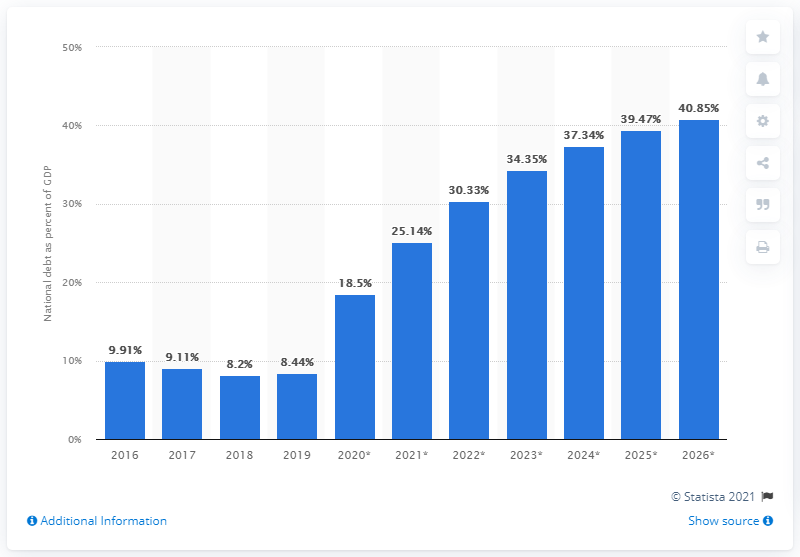What information does the chart provide about Estonia's national debt? The chart displays Estonia's national debt as a percentage of GDP from 2016 to 2026. The figures for 2021 to 2026 are projections. The trend indicates an increase in the national debt relative to GDP over the years, with a marked uptick in the projected values from 2021 onwards. What could be the reason for the projected increase in national debt? The projected increase in national debt could be attributed to various factors, such as government investment in public services or infrastructure, economic stimulus measures, or the impacts of global economic challenges such as those caused by the COVID-19 pandemic. 